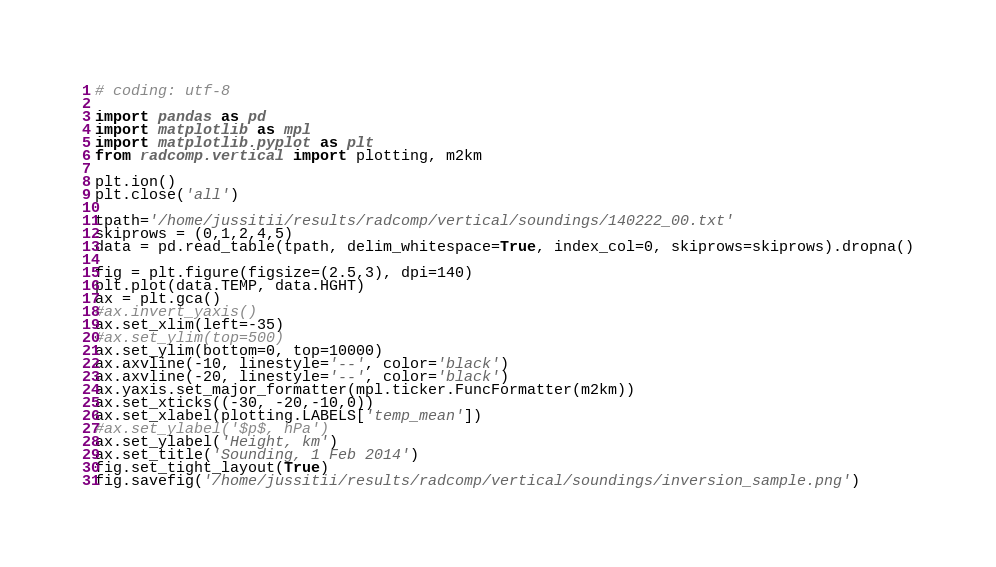<code> <loc_0><loc_0><loc_500><loc_500><_Python_># coding: utf-8

import pandas as pd
import matplotlib as mpl
import matplotlib.pyplot as plt
from radcomp.vertical import plotting, m2km

plt.ion()
plt.close('all')

tpath='/home/jussitii/results/radcomp/vertical/soundings/140222_00.txt'
skiprows = (0,1,2,4,5)
data = pd.read_table(tpath, delim_whitespace=True, index_col=0, skiprows=skiprows).dropna()

fig = plt.figure(figsize=(2.5,3), dpi=140)
plt.plot(data.TEMP, data.HGHT)
ax = plt.gca()
#ax.invert_yaxis()
ax.set_xlim(left=-35)
#ax.set_ylim(top=500)
ax.set_ylim(bottom=0, top=10000)
ax.axvline(-10, linestyle='--', color='black')
ax.axvline(-20, linestyle='--', color='black')
ax.yaxis.set_major_formatter(mpl.ticker.FuncFormatter(m2km))
ax.set_xticks((-30, -20,-10,0))
ax.set_xlabel(plotting.LABELS['temp_mean'])
#ax.set_ylabel('$p$, hPa')
ax.set_ylabel('Height, km')
ax.set_title('Sounding, 1 Feb 2014')
fig.set_tight_layout(True)
fig.savefig('/home/jussitii/results/radcomp/vertical/soundings/inversion_sample.png')
</code> 